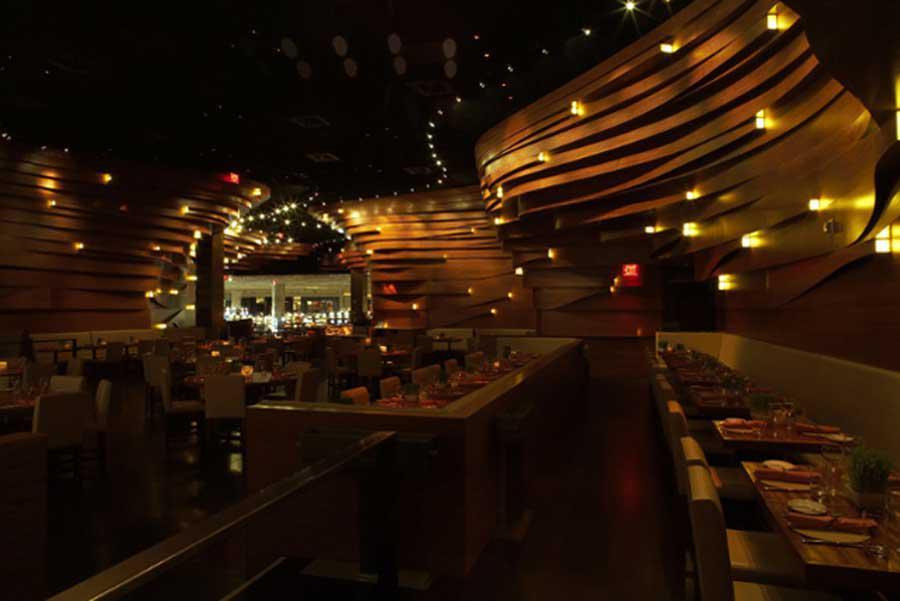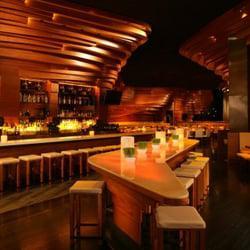The first image is the image on the left, the second image is the image on the right. For the images displayed, is the sentence "The left image contains at least one chandelier." factually correct? Answer yes or no. No. The first image is the image on the left, the second image is the image on the right. Analyze the images presented: Is the assertion "The left image shows an interior with lights in a circle suspended from the ceiling, and the right image shows an interior with sculpted curving walls facing rows of seats." valid? Answer yes or no. No. 